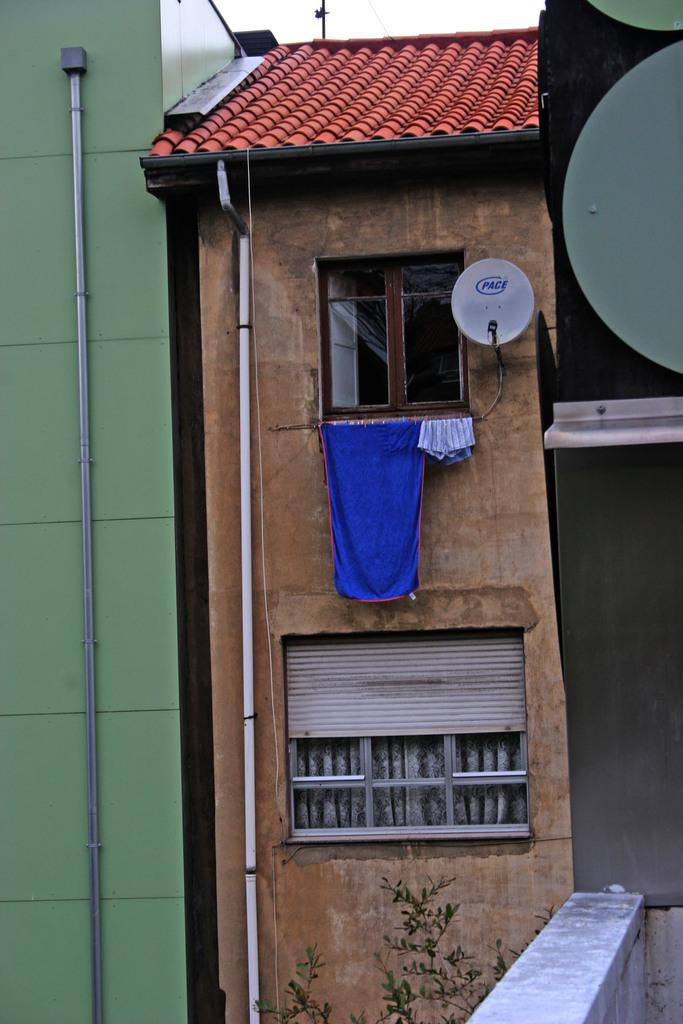What type of structures are present in the image? There are buildings in the image. What colors can be seen on the buildings? The buildings have brown and green colors. What else can be seen in the image besides the buildings? There are clothes and glass windows visible in the image. What is the color of the sky in the background? The sky in the background is white. Can you see a bear walking in the image? There is no bear present in the image. What type of bird can be seen flying in the image? There are no birds visible in the image. 